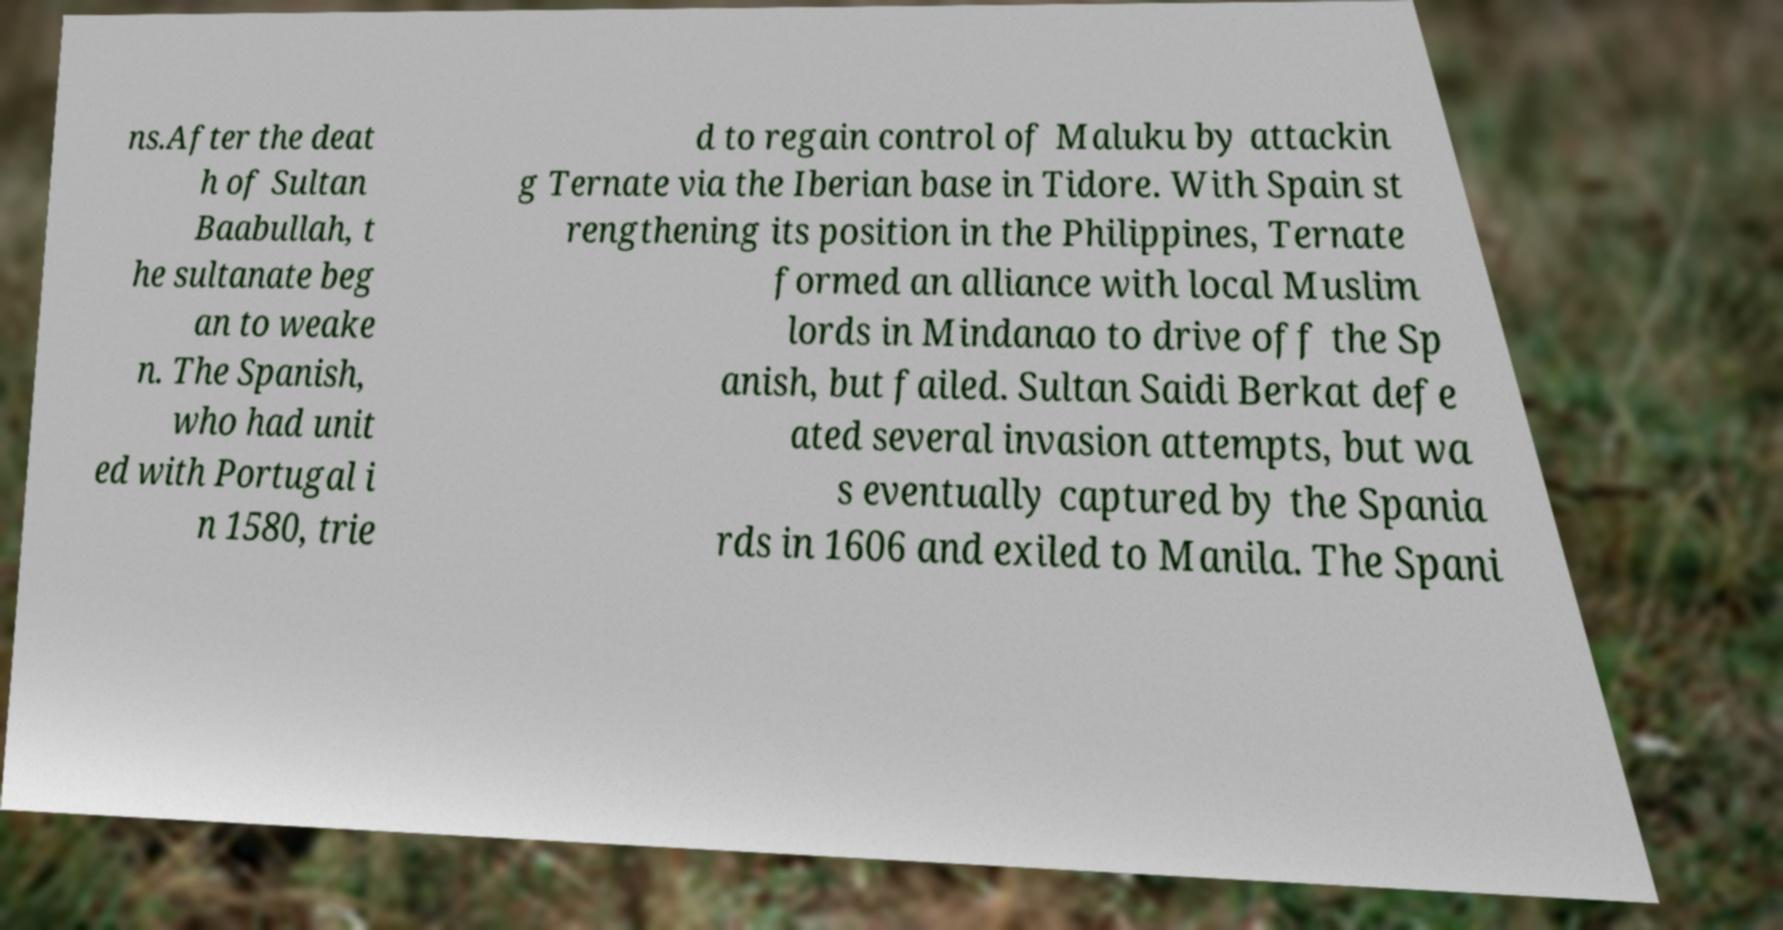Please identify and transcribe the text found in this image. ns.After the deat h of Sultan Baabullah, t he sultanate beg an to weake n. The Spanish, who had unit ed with Portugal i n 1580, trie d to regain control of Maluku by attackin g Ternate via the Iberian base in Tidore. With Spain st rengthening its position in the Philippines, Ternate formed an alliance with local Muslim lords in Mindanao to drive off the Sp anish, but failed. Sultan Saidi Berkat defe ated several invasion attempts, but wa s eventually captured by the Spania rds in 1606 and exiled to Manila. The Spani 